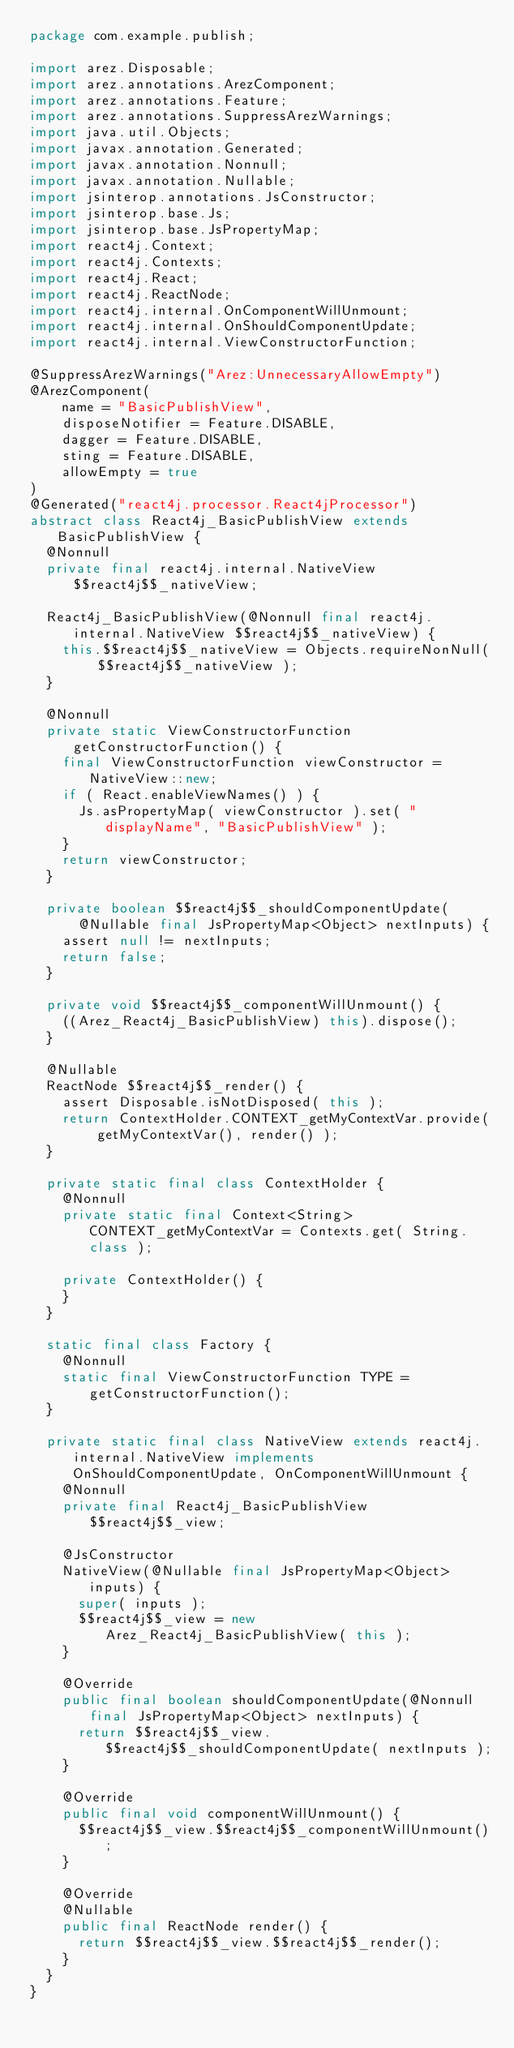Convert code to text. <code><loc_0><loc_0><loc_500><loc_500><_Java_>package com.example.publish;

import arez.Disposable;
import arez.annotations.ArezComponent;
import arez.annotations.Feature;
import arez.annotations.SuppressArezWarnings;
import java.util.Objects;
import javax.annotation.Generated;
import javax.annotation.Nonnull;
import javax.annotation.Nullable;
import jsinterop.annotations.JsConstructor;
import jsinterop.base.Js;
import jsinterop.base.JsPropertyMap;
import react4j.Context;
import react4j.Contexts;
import react4j.React;
import react4j.ReactNode;
import react4j.internal.OnComponentWillUnmount;
import react4j.internal.OnShouldComponentUpdate;
import react4j.internal.ViewConstructorFunction;

@SuppressArezWarnings("Arez:UnnecessaryAllowEmpty")
@ArezComponent(
    name = "BasicPublishView",
    disposeNotifier = Feature.DISABLE,
    dagger = Feature.DISABLE,
    sting = Feature.DISABLE,
    allowEmpty = true
)
@Generated("react4j.processor.React4jProcessor")
abstract class React4j_BasicPublishView extends BasicPublishView {
  @Nonnull
  private final react4j.internal.NativeView $$react4j$$_nativeView;

  React4j_BasicPublishView(@Nonnull final react4j.internal.NativeView $$react4j$$_nativeView) {
    this.$$react4j$$_nativeView = Objects.requireNonNull( $$react4j$$_nativeView );
  }

  @Nonnull
  private static ViewConstructorFunction getConstructorFunction() {
    final ViewConstructorFunction viewConstructor = NativeView::new;
    if ( React.enableViewNames() ) {
      Js.asPropertyMap( viewConstructor ).set( "displayName", "BasicPublishView" );
    }
    return viewConstructor;
  }

  private boolean $$react4j$$_shouldComponentUpdate(
      @Nullable final JsPropertyMap<Object> nextInputs) {
    assert null != nextInputs;
    return false;
  }

  private void $$react4j$$_componentWillUnmount() {
    ((Arez_React4j_BasicPublishView) this).dispose();
  }

  @Nullable
  ReactNode $$react4j$$_render() {
    assert Disposable.isNotDisposed( this );
    return ContextHolder.CONTEXT_getMyContextVar.provide( getMyContextVar(), render() );
  }

  private static final class ContextHolder {
    @Nonnull
    private static final Context<String> CONTEXT_getMyContextVar = Contexts.get( String.class );

    private ContextHolder() {
    }
  }

  static final class Factory {
    @Nonnull
    static final ViewConstructorFunction TYPE = getConstructorFunction();
  }

  private static final class NativeView extends react4j.internal.NativeView implements OnShouldComponentUpdate, OnComponentWillUnmount {
    @Nonnull
    private final React4j_BasicPublishView $$react4j$$_view;

    @JsConstructor
    NativeView(@Nullable final JsPropertyMap<Object> inputs) {
      super( inputs );
      $$react4j$$_view = new Arez_React4j_BasicPublishView( this );
    }

    @Override
    public final boolean shouldComponentUpdate(@Nonnull final JsPropertyMap<Object> nextInputs) {
      return $$react4j$$_view.$$react4j$$_shouldComponentUpdate( nextInputs );
    }

    @Override
    public final void componentWillUnmount() {
      $$react4j$$_view.$$react4j$$_componentWillUnmount();
    }

    @Override
    @Nullable
    public final ReactNode render() {
      return $$react4j$$_view.$$react4j$$_render();
    }
  }
}
</code> 